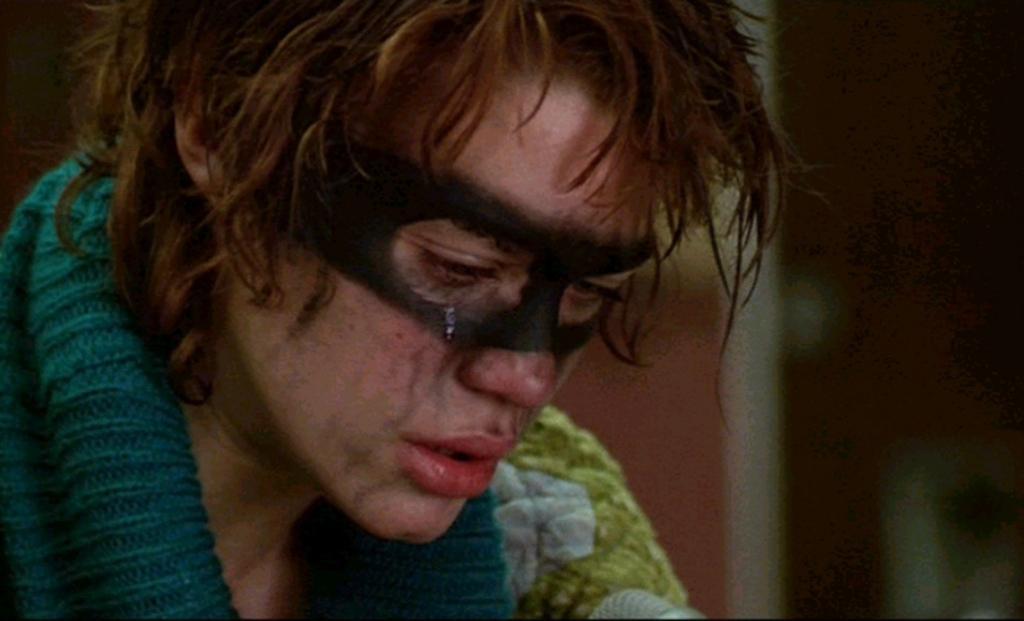How would you summarize this image in a sentence or two? In this image I can see the person and the person is wearing green and white color dress and I can see the blurred background. 